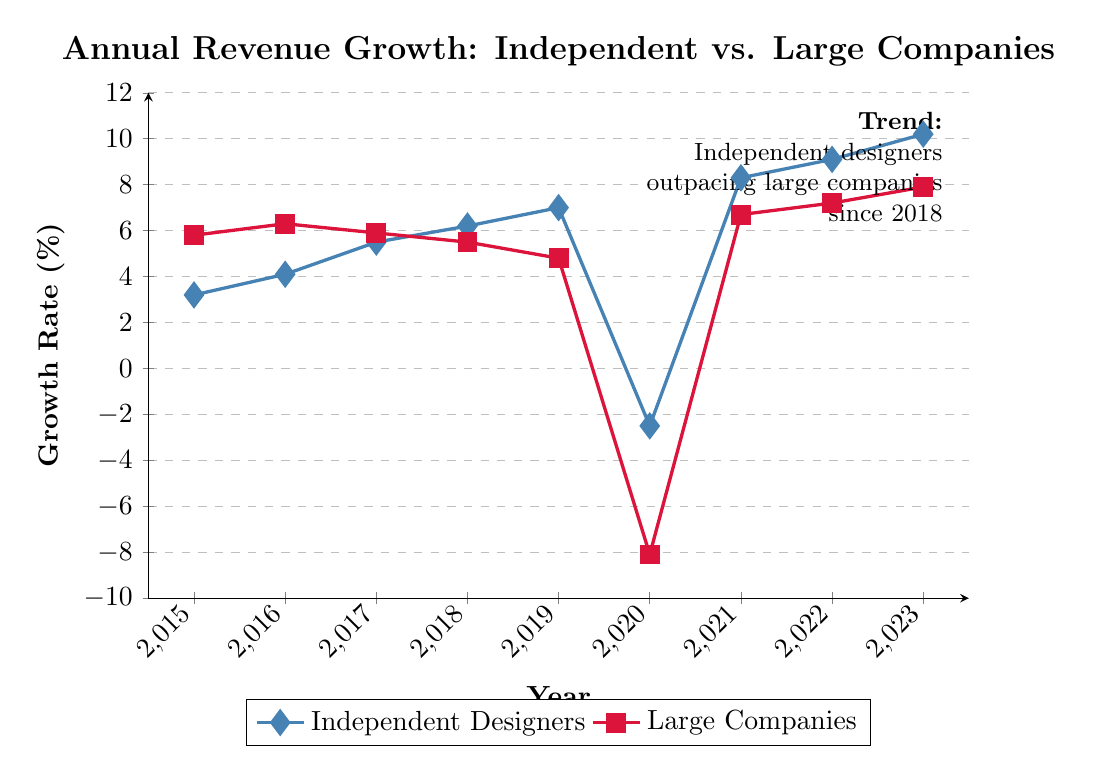What was the annual revenue growth rate for independent designers in 2017? To answer this, look at the point where the "Independent Designers" line intersects the year 2017. The growth rate is labeled next to that point.
Answer: 5.5% How did the revenue growth rate for large companies change from 2019 to 2020? Compare the growth rate values for large companies in 2019 and 2020. In 2019, the growth rate was 4.8%. In 2020, it dropped to -8.1%. Calculate the difference to find out how much it changed.
Answer: Decreased by 12.9% In which year did independent designers experience the highest growth rate? Identify the highest point on the "Independent Designers" line. Look at the year associated with that point.
Answer: 2023 By how much did independent designers' growth rate exceed that of large companies in 2021? For 2021, find the growth rates for both independent designers and large companies: 8.3% and 6.7%, respectively. Subtract the large companies' rate from the independent designers' rate to get the difference.
Answer: 1.6% Which group had a positive growth rate in 2020, and what was the rate? Identify the growth rates for both groups in 2020. Only independent designers had a positive growth rate (-2.5% compared to -8.1%). Although independent designers had a less negative rate, it was still not positive. Therefore, the answer recognizes a mistake in the premise since both groups had negative rates.
Answer: Neither How many times did the growth rate for independent designers increase consecutively from 2015 to 2023? Track the values for independent designers from 2015 to 2023 and count the number of consecutive increases. (3.2% to 4.1%, 4.1% to 5.5%, 5.5% to 6.2%, 6.2% to 7.0%, and from 8.3% to 10.2%).
Answer: 5 times Which group had a higher growth rate in 2018, and by how much? Compare the growth rates for both groups in 2018: independent designers (6.2%) and large companies (5.5%). Subtract the smaller value from the larger one.
Answer: Independent designers by 0.7% What is the average growth rate for large companies from 2015 to 2019? Add the growth rates of large companies from 2015 to 2019: 5.8%, 6.3%, 5.9%, 5.5%, and 4.8%. Sum these values and divide by the number of years (5).
Answer: 5.66% Did independent designers or large companies show a larger improvement in their growth rate from 2020 to 2021? Calculate the change for each group from 2020 to 2021: Independent designers (-2.5% to 8.3%) improved by (8.3% - (-2.5%)) = 10.8%, and large companies (-8.1% to 6.7%) improved by (6.7% - (-8.1%)) = 14.8%. Compare these values.
Answer: Large companies What notable trend is highlighted in the annotation of the plot? Read the text presented in the annotation of the plot, which describes a key observation based on the visual data.
Answer: Independent designers outpacing large companies since 2018 